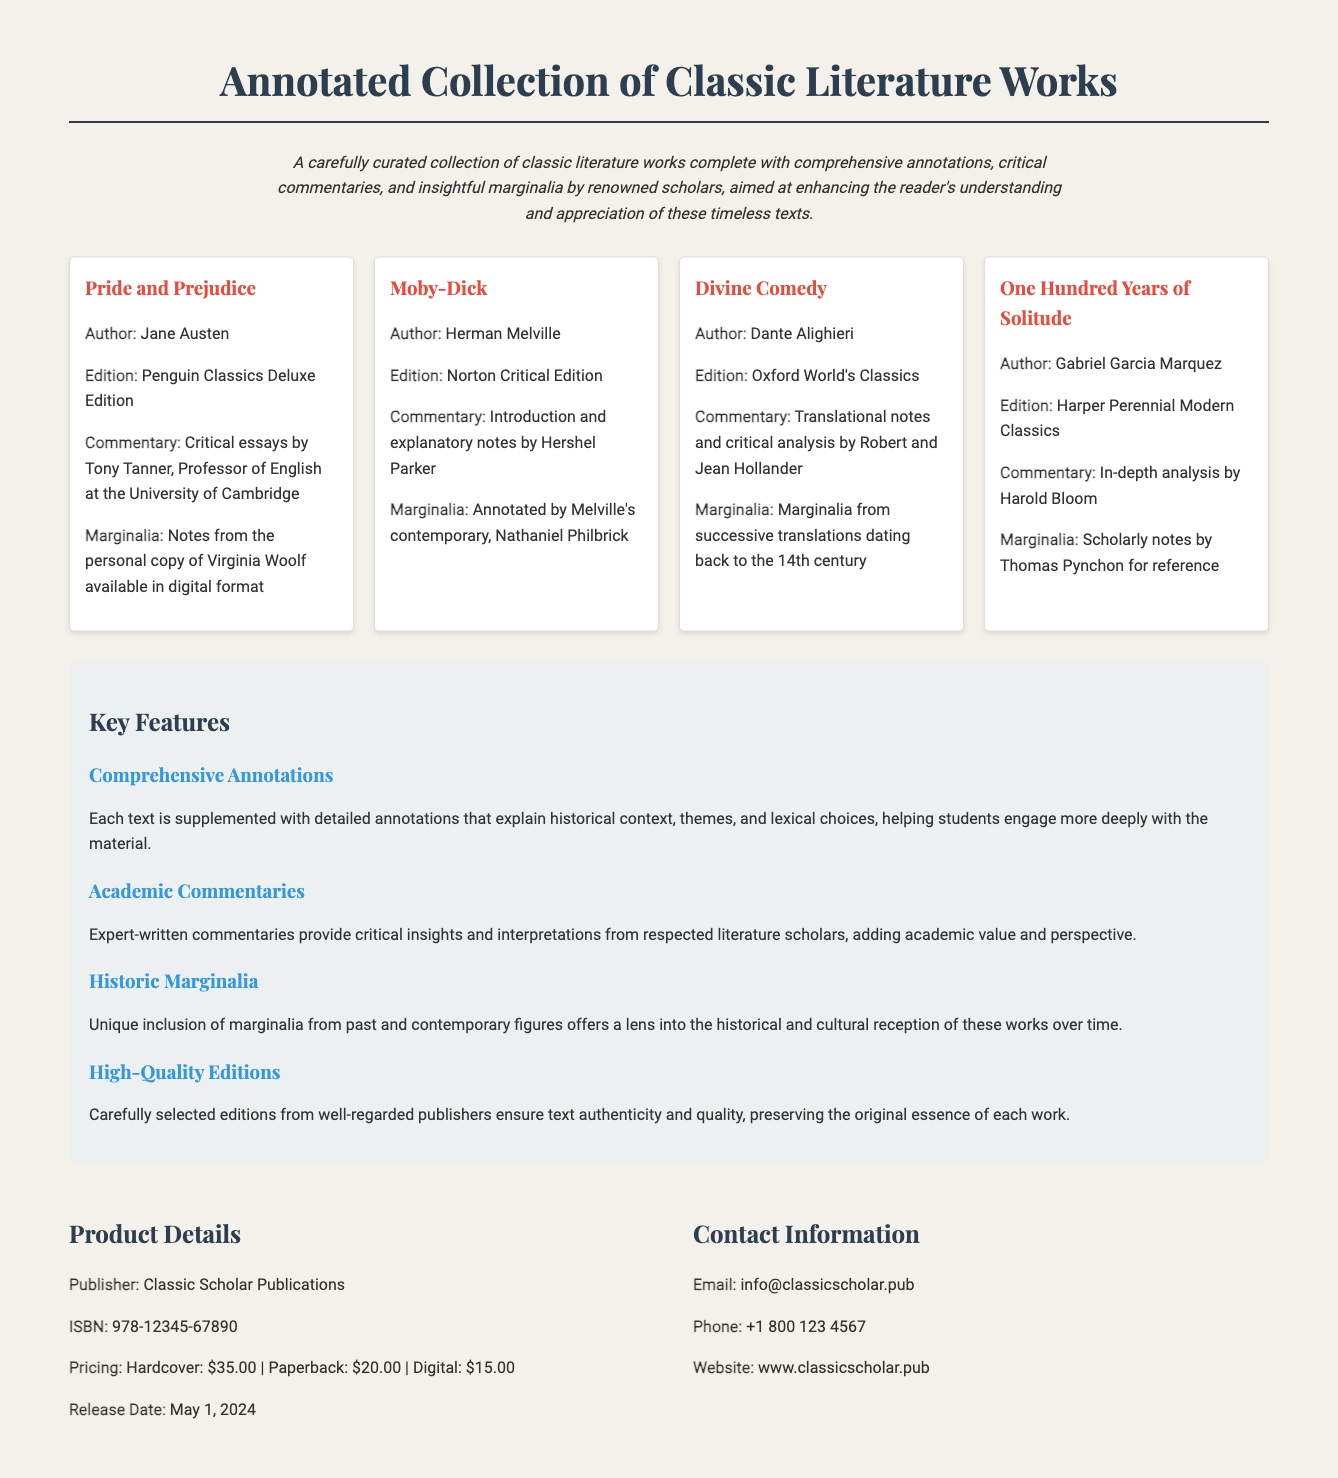what is the title of the collection? The title can be found prominently at the top of the document.
Answer: Annotated Collection of Classic Literature Works who is the author of "Pride and Prejudice"? The author of "Pride and Prejudice" is detailed within the work cards in the document.
Answer: Jane Austen which edition of "Moby-Dick" is included? The edition information is specified under each work card in the collection.
Answer: Norton Critical Edition what is the price of the digital edition? Pricing details are provided in the product details section.
Answer: $15.00 who provided the commentary for "Divine Comedy"? This information is included in the work card for "Divine Comedy".
Answer: Robert and Jean Hollander what type of marginalia is included for "One Hundred Years of Solitude"? The type of marginalia can be found in the respective work card's description.
Answer: Scholarly notes by Thomas Pynchon which publisher produced this collection? Publisher information is listed in the product details section of the document.
Answer: Classic Scholar Publications what is the release date of the collection? The release date for the collection can be found in the product details.
Answer: May 1, 2024 how many key features are listed in the document? The number of key features can be counted from the features section.
Answer: Four 